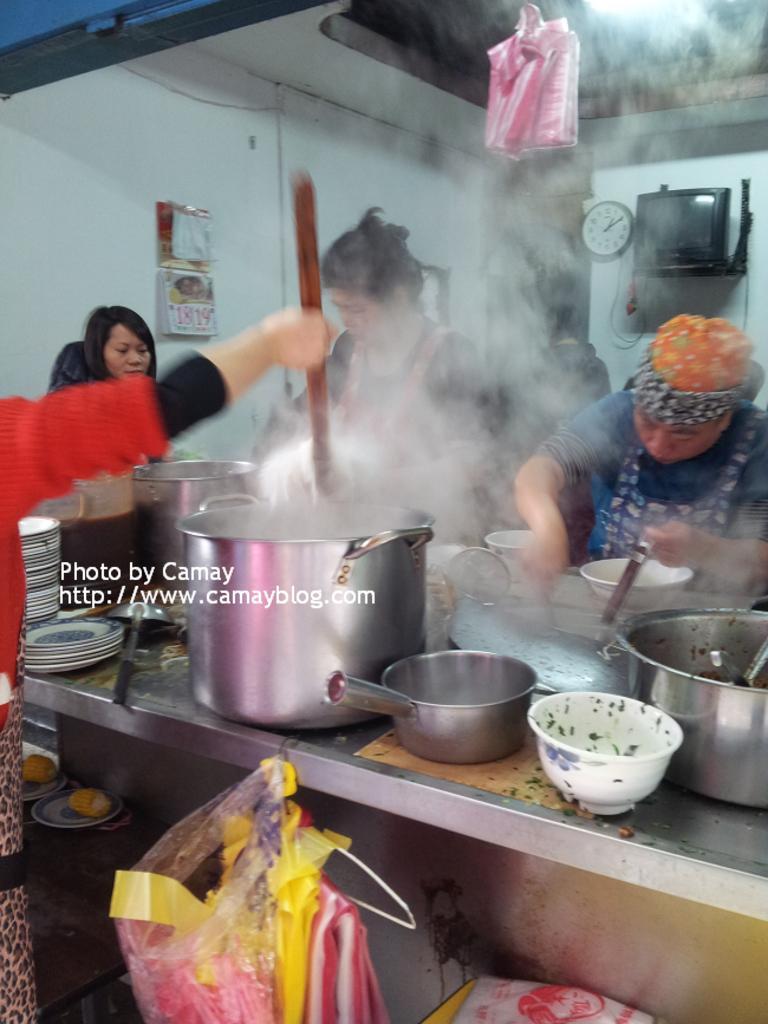In one or two sentences, can you explain what this image depicts? There is a table. On the table there are vessels, plates and many other items. Near to the table there are some people standing. Also there are covers and plates with food items. In the back there's a wall with a calendar, TV, and a clock. Also there is smoke. On the ceiling there is light. 